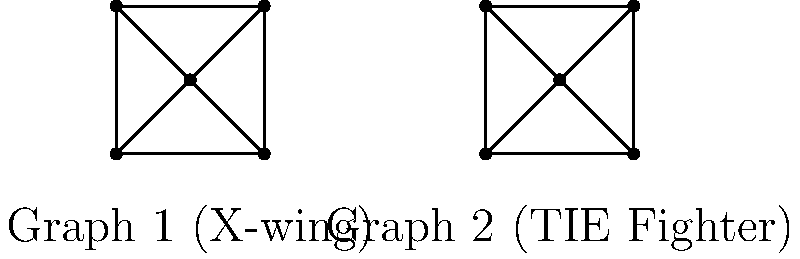Consider the two graphs representing simplified designs of Star Wars spacecraft: Graph 1 (X-wing) and Graph 2 (TIE Fighter). Are these graphs isomorphic? If so, provide a bijective function $f$ that maps the vertices of Graph 1 to Graph 2, preserving the edge connections. To determine if the graphs are isomorphic, we need to check if there exists a bijective function that maps the vertices of one graph to the other while preserving the edge connections. Let's approach this step-by-step:

1. Both graphs have 5 vertices and 8 edges, which is a necessary (but not sufficient) condition for isomorphism.

2. In both graphs, we can identify a central vertex (degree 4) connected to four outer vertices (each of degree 3).

3. The edge connections are identical in both graphs:
   - The central vertex is connected to all other vertices.
   - The outer vertices form a cycle.

4. We can define a bijective function $f$ that maps the vertices of Graph 1 to Graph 2:
   Let the vertices of Graph 1 be $a, b, c, d, e$ (where $a$ is the center),
   and the vertices of Graph 2 be $v, w, x, y, z$ (where $v$ is the center).

   $f(a) = v$ (center to center)
   $f(b) = w$ (top-right to top-right)
   $f(c) = x$ (bottom-right to bottom-right)
   $f(d) = y$ (top-left to top-left)
   $f(e) = z$ (bottom-left to bottom-left)

5. This function $f$ preserves all edge connections:
   - $a$ is connected to $b, c, d, e$, and $v$ is connected to $w, x, y, z$.
   - The outer vertices $b-d-e-c-b$ form a cycle, as do $w-y-z-x-w$.

Therefore, the graphs are isomorphic, and we have provided a bijective function $f$ that demonstrates this isomorphism.
Answer: Yes, isomorphic. $f(a)=v, f(b)=w, f(c)=x, f(d)=y, f(e)=z$. 